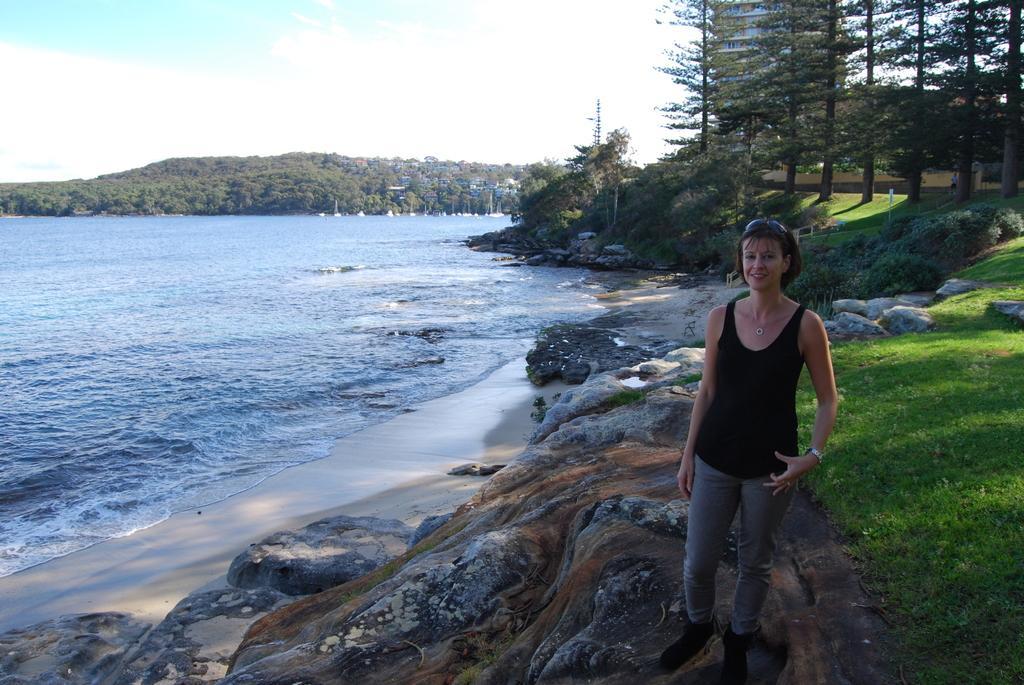Could you give a brief overview of what you see in this image? In this image there is a river, a woman standing on the bank of a river, in the back ground there there are trees, mountains and a sky. 